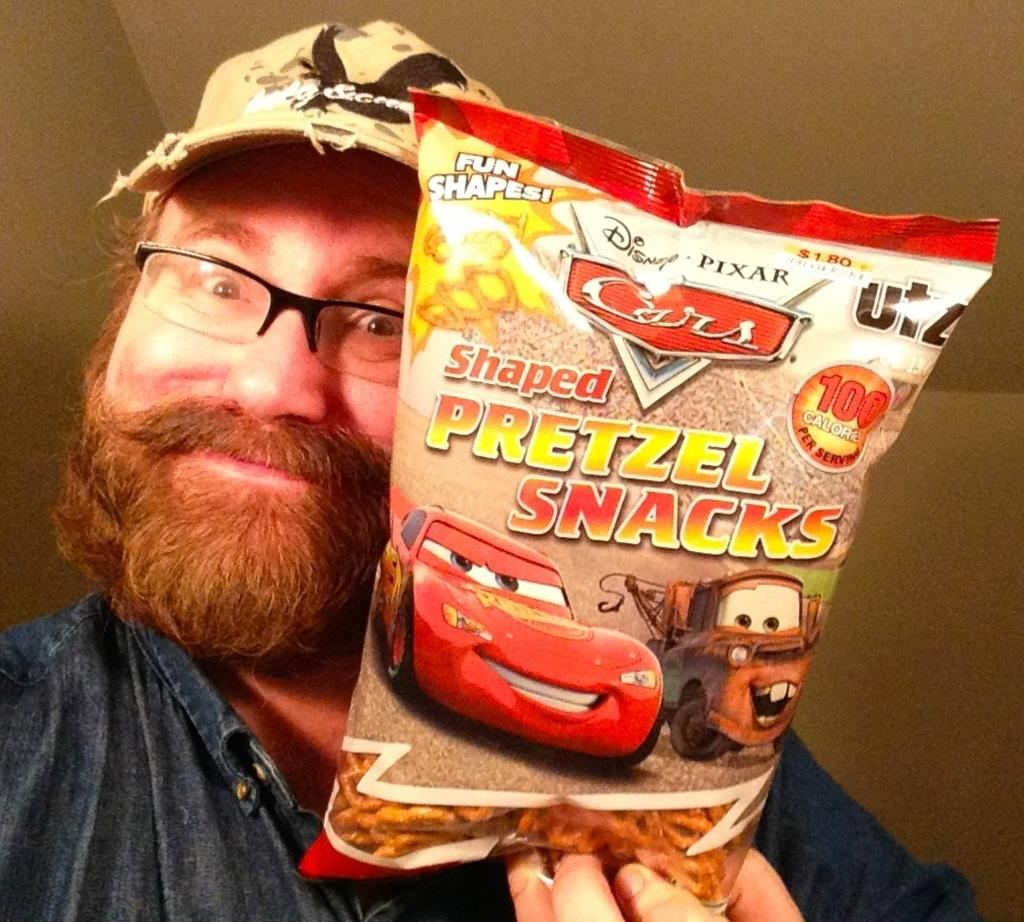What can be seen in the image? There is a person in the image. What is the person doing in the image? The person is holding an object. What else is visible in the image besides the person? There is a wall visible in the image. What type of route is the person following in the image? There is no route visible in the image, as it only shows a person holding an object and a wall in the background. 